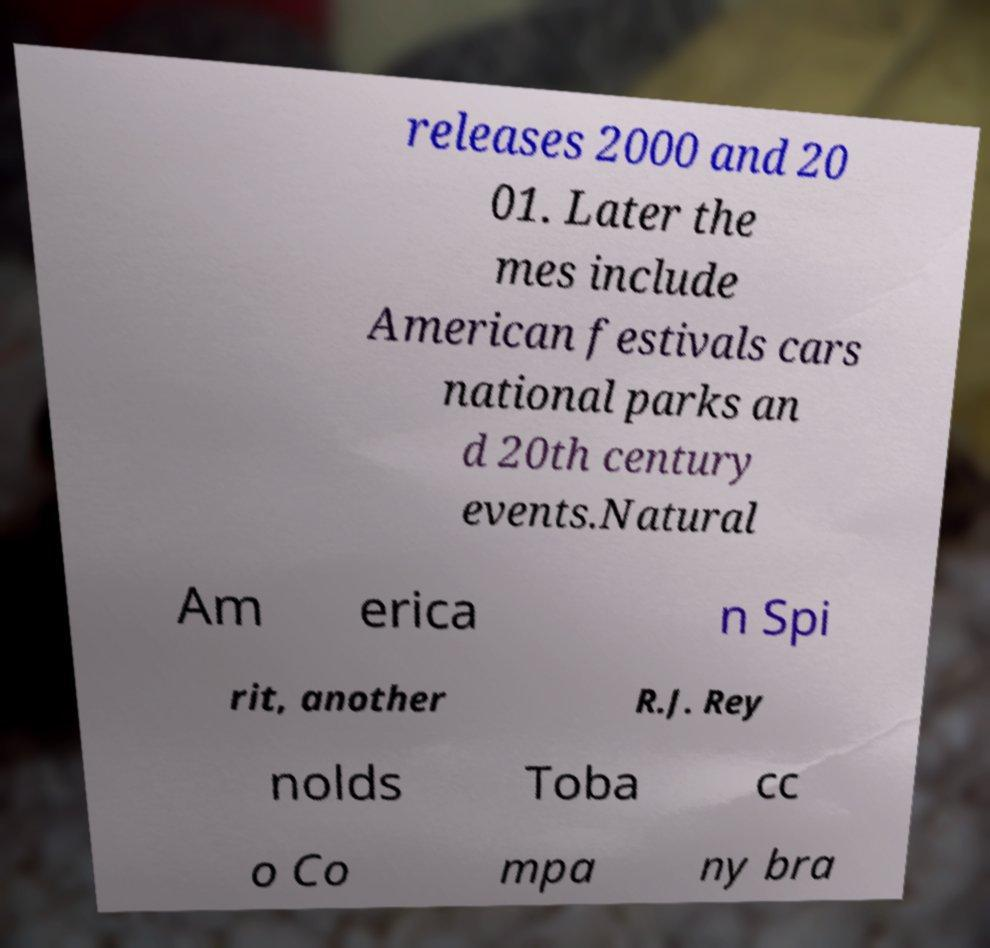Can you accurately transcribe the text from the provided image for me? releases 2000 and 20 01. Later the mes include American festivals cars national parks an d 20th century events.Natural Am erica n Spi rit, another R.J. Rey nolds Toba cc o Co mpa ny bra 